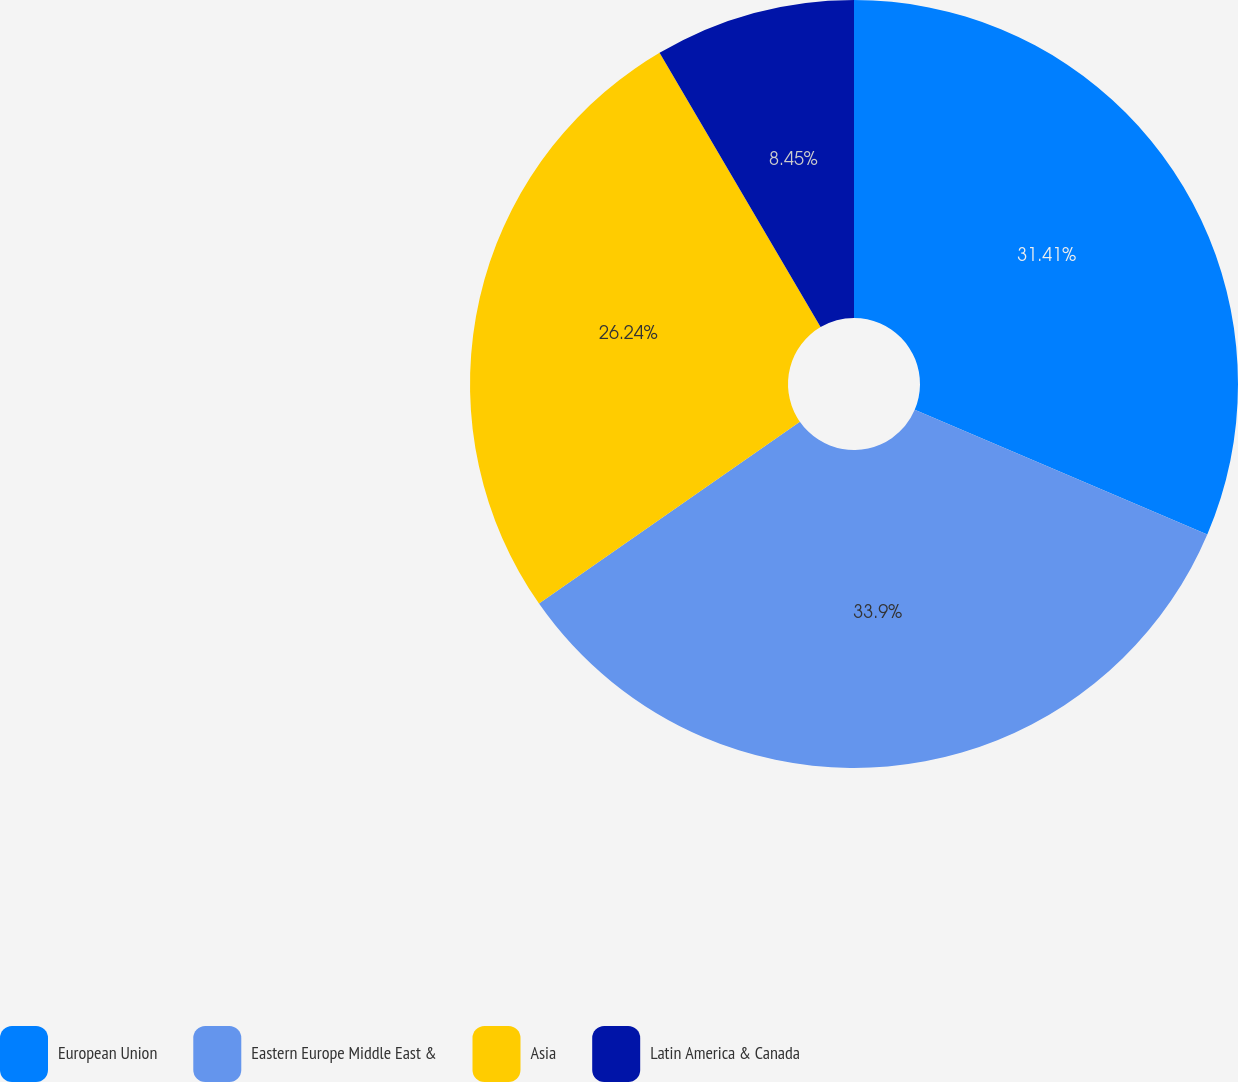Convert chart to OTSL. <chart><loc_0><loc_0><loc_500><loc_500><pie_chart><fcel>European Union<fcel>Eastern Europe Middle East &<fcel>Asia<fcel>Latin America & Canada<nl><fcel>31.41%<fcel>33.9%<fcel>26.24%<fcel>8.45%<nl></chart> 